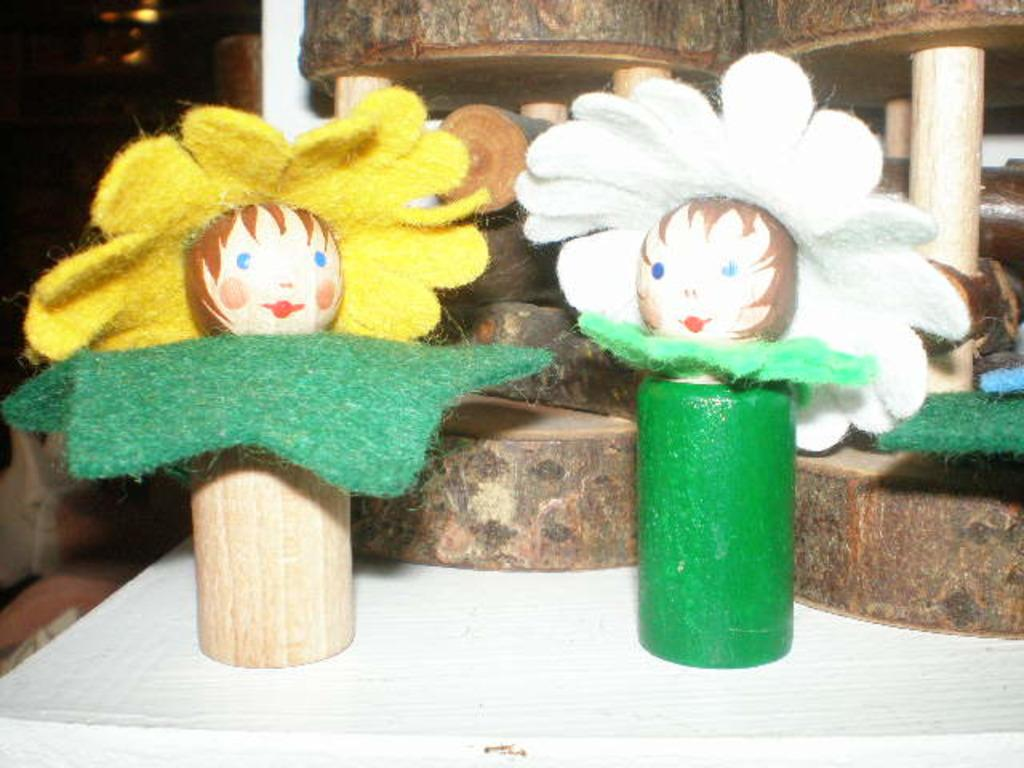What type of objects are present in the image? There are miniatures in the image. Can you describe the background of the image? The background of the image is dark. How many bites can be taken out of the miniatures in the image? There are no bites taken out of the miniatures in the image, as they are likely inanimate objects. 